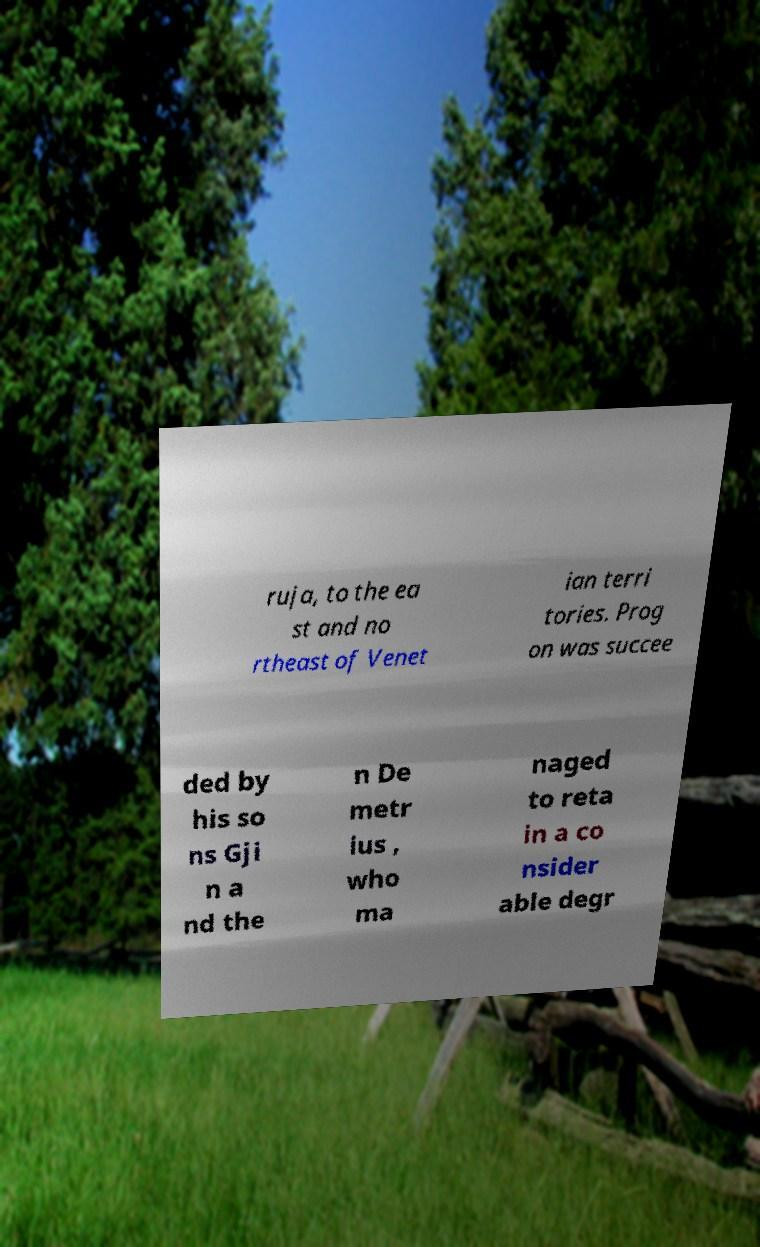Can you read and provide the text displayed in the image?This photo seems to have some interesting text. Can you extract and type it out for me? ruja, to the ea st and no rtheast of Venet ian terri tories. Prog on was succee ded by his so ns Gji n a nd the n De metr ius , who ma naged to reta in a co nsider able degr 